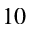Convert formula to latex. <formula><loc_0><loc_0><loc_500><loc_500>^ { 1 0 }</formula> 